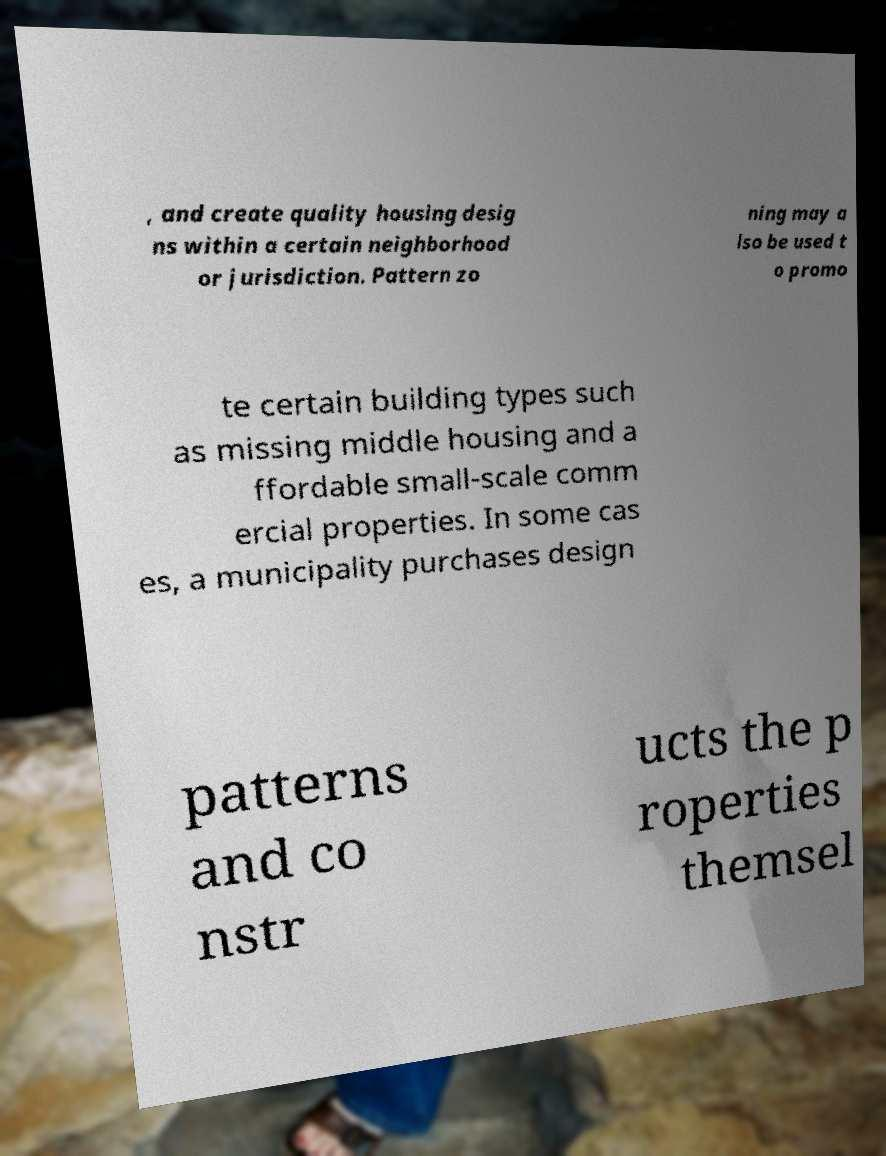Could you extract and type out the text from this image? , and create quality housing desig ns within a certain neighborhood or jurisdiction. Pattern zo ning may a lso be used t o promo te certain building types such as missing middle housing and a ffordable small-scale comm ercial properties. In some cas es, a municipality purchases design patterns and co nstr ucts the p roperties themsel 